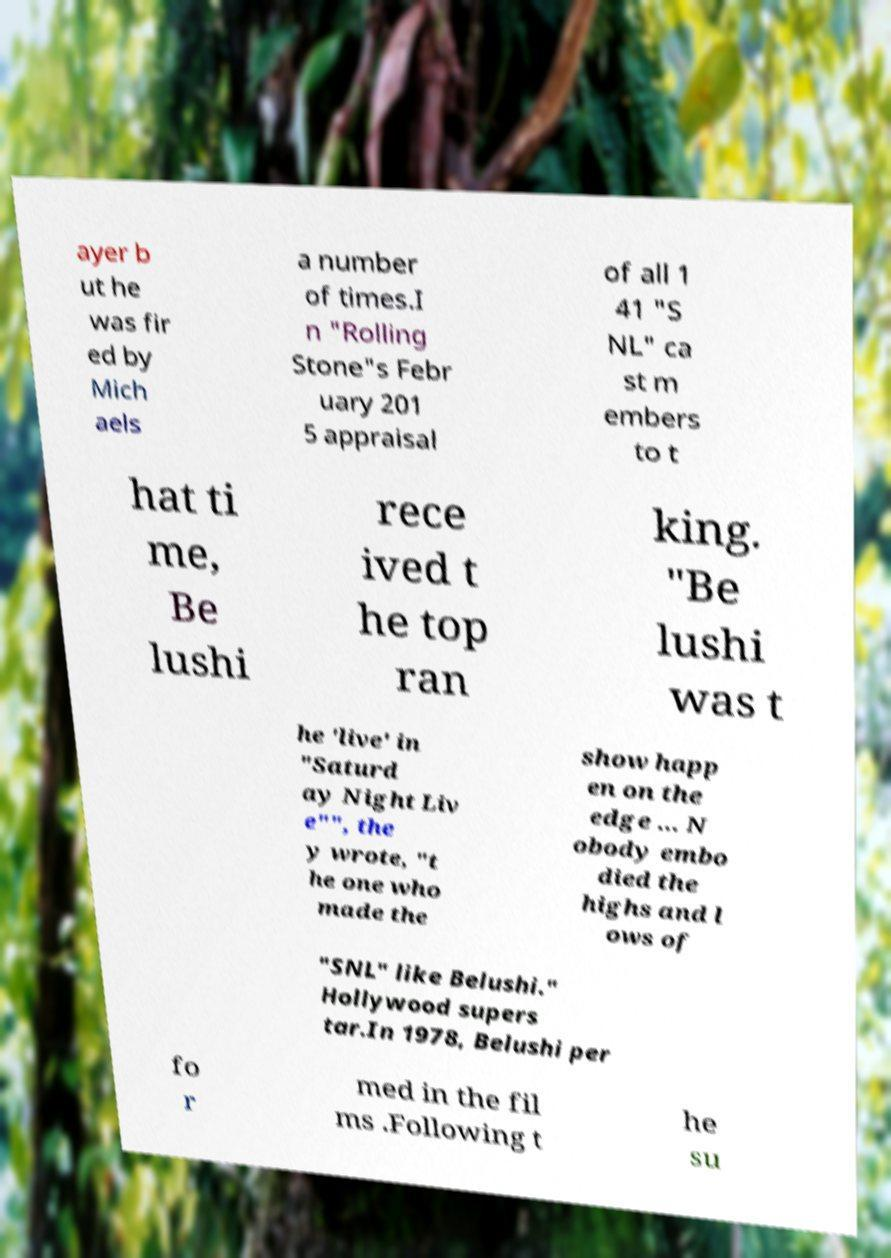Please read and relay the text visible in this image. What does it say? ayer b ut he was fir ed by Mich aels a number of times.I n "Rolling Stone"s Febr uary 201 5 appraisal of all 1 41 "S NL" ca st m embers to t hat ti me, Be lushi rece ived t he top ran king. "Be lushi was t he 'live' in "Saturd ay Night Liv e"", the y wrote, "t he one who made the show happ en on the edge ... N obody embo died the highs and l ows of "SNL" like Belushi." Hollywood supers tar.In 1978, Belushi per fo r med in the fil ms .Following t he su 